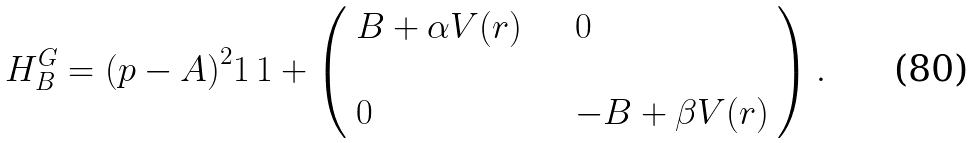<formula> <loc_0><loc_0><loc_500><loc_500>H ^ { G } _ { B } = { ( p - A ) } ^ { 2 } 1 \, 1 + \left ( \begin{array} { l l } B + \alpha V ( r ) \quad & 0 \\ \\ 0 & - B + \beta V ( r ) \end{array} \right ) .</formula> 